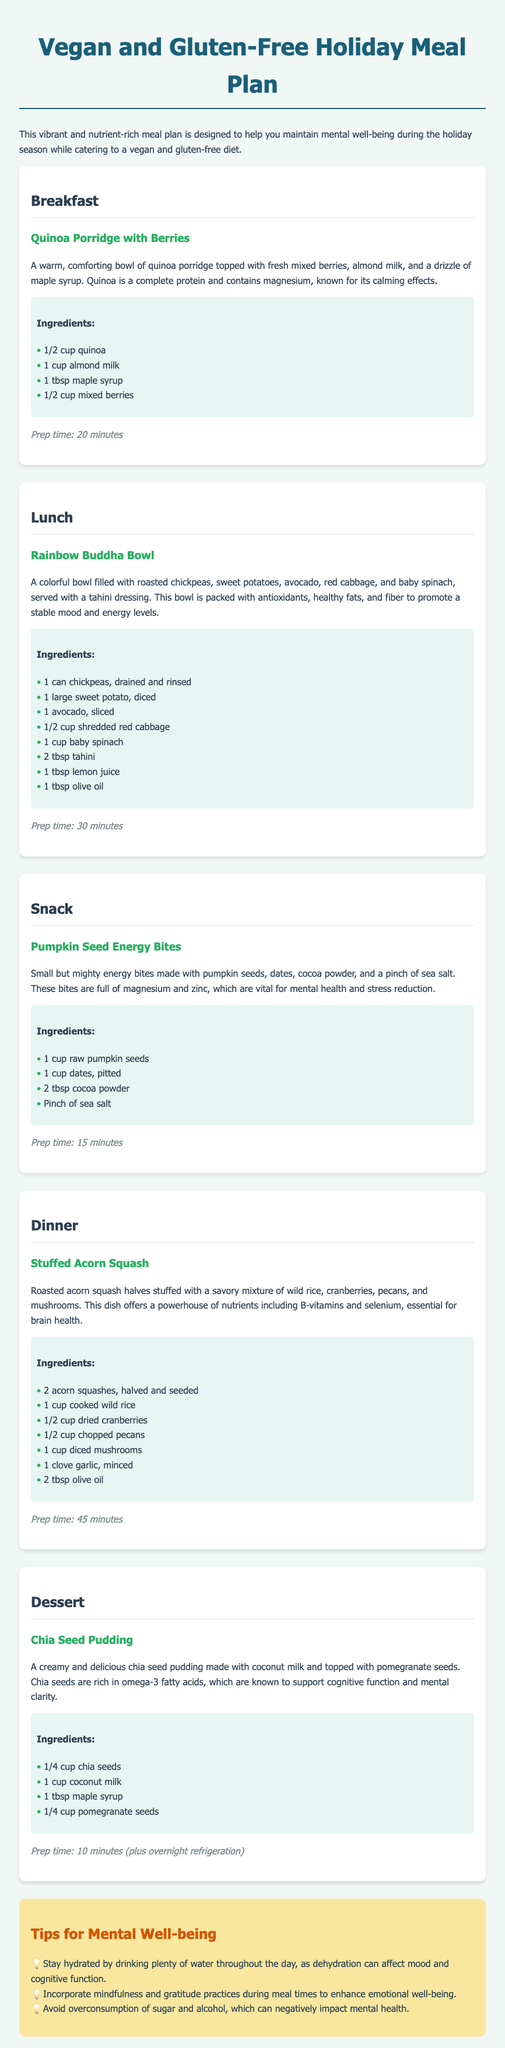What is the title of the meal plan? The title of the meal plan is prominently displayed at the top of the document.
Answer: Vegan and Gluten-Free Holiday Meal Plan What type of milk is used in the breakfast dish? The breakfast dish specifies the type of milk used in its preparation.
Answer: Almond milk How long does it take to prepare the Stuffed Acorn Squash? The document provides the prep time for this specific dinner dish.
Answer: 45 minutes What are the main ingredients in the Rainbow Buddha Bowl? This question requires identifying key ingredients listed for the lunch dish.
Answer: Chickpeas, sweet potatoes, avocado, red cabbage, baby spinach Which meal is a dessert in this plan? The dessert meal is explicitly labeled within the meal plan.
Answer: Chia Seed Pudding What is a suggested tip for mental well-being? The tips section contains several suggestions for enhancing mental health which serves as an inquiry into its content.
Answer: Stay hydrated How many different meals are included in the plan? The document outlines various meal categories, indicating quantity.
Answer: Five What are the main nutrients mentioned in relation to Chia Seed Pudding? Understanding the benefits requires synthesizing information about the nutrient content of the dish.
Answer: Omega-3 fatty acids 